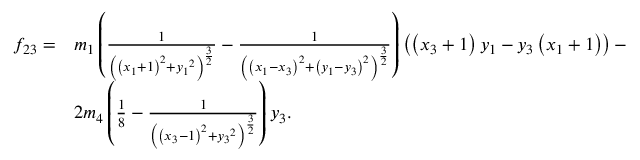Convert formula to latex. <formula><loc_0><loc_0><loc_500><loc_500>\begin{array} { l l } { f _ { 2 3 } = } & { { m _ { 1 } } \left ( \frac { 1 } { \left ( \left ( { x _ { 1 } } + 1 \right ) ^ { 2 } + { y _ { 1 } } ^ { 2 } \right ) ^ { \frac { 3 } { 2 } } } - \frac { 1 } { \left ( \left ( { x _ { 1 } } - { x _ { 3 } } \right ) ^ { 2 } + \left ( { y _ { 1 } } - { y _ { 3 } } \right ) ^ { 2 } \right ) ^ { \frac { 3 } { 2 } } } \right ) \left ( \left ( { x _ { 3 } } + 1 \right ) { y _ { 1 } } - { y _ { 3 } } \left ( { x _ { 1 } } + 1 \right ) \right ) - } \\ & { 2 { m _ { 4 } } \left ( \frac { 1 } { 8 } - \frac { 1 } { \left ( \left ( { x _ { 3 } } - 1 \right ) ^ { 2 } + { y _ { 3 } } ^ { 2 } \right ) ^ { \frac { 3 } { 2 } } } \right ) { y _ { 3 } } . } \end{array}</formula> 